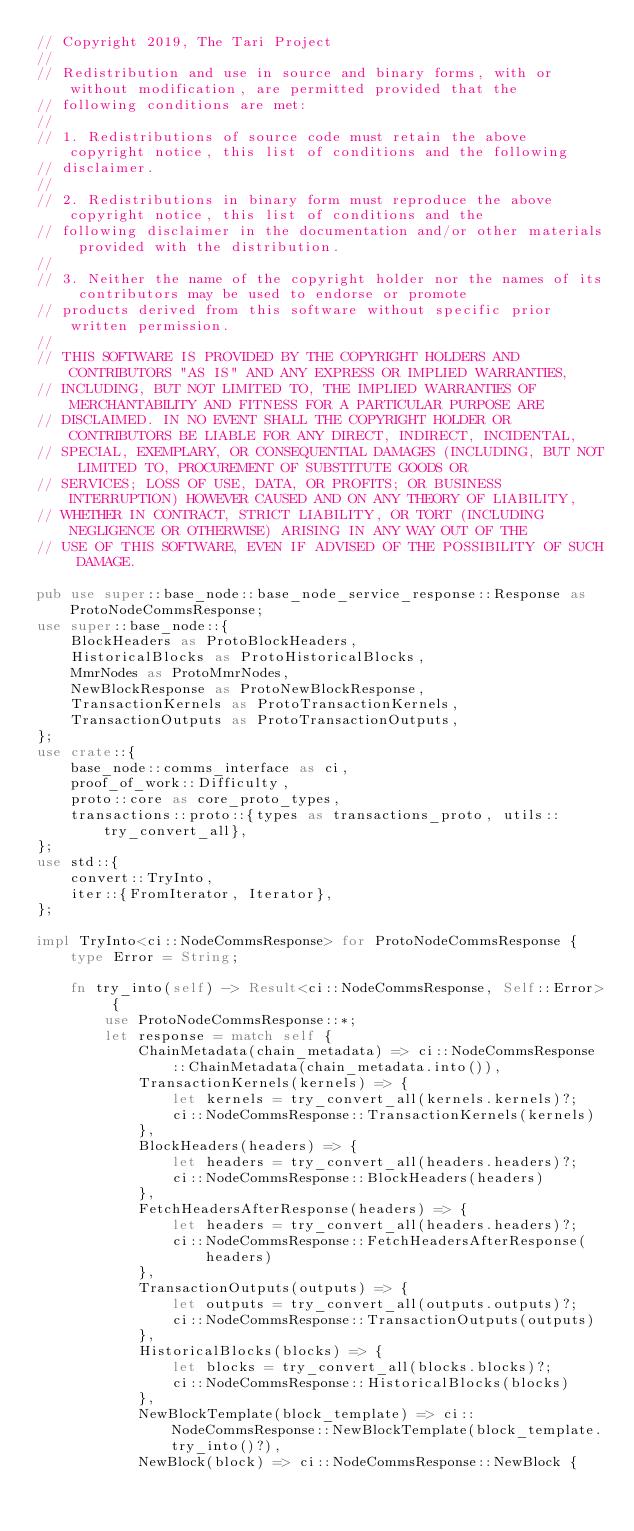Convert code to text. <code><loc_0><loc_0><loc_500><loc_500><_Rust_>// Copyright 2019, The Tari Project
//
// Redistribution and use in source and binary forms, with or without modification, are permitted provided that the
// following conditions are met:
//
// 1. Redistributions of source code must retain the above copyright notice, this list of conditions and the following
// disclaimer.
//
// 2. Redistributions in binary form must reproduce the above copyright notice, this list of conditions and the
// following disclaimer in the documentation and/or other materials provided with the distribution.
//
// 3. Neither the name of the copyright holder nor the names of its contributors may be used to endorse or promote
// products derived from this software without specific prior written permission.
//
// THIS SOFTWARE IS PROVIDED BY THE COPYRIGHT HOLDERS AND CONTRIBUTORS "AS IS" AND ANY EXPRESS OR IMPLIED WARRANTIES,
// INCLUDING, BUT NOT LIMITED TO, THE IMPLIED WARRANTIES OF MERCHANTABILITY AND FITNESS FOR A PARTICULAR PURPOSE ARE
// DISCLAIMED. IN NO EVENT SHALL THE COPYRIGHT HOLDER OR CONTRIBUTORS BE LIABLE FOR ANY DIRECT, INDIRECT, INCIDENTAL,
// SPECIAL, EXEMPLARY, OR CONSEQUENTIAL DAMAGES (INCLUDING, BUT NOT LIMITED TO, PROCUREMENT OF SUBSTITUTE GOODS OR
// SERVICES; LOSS OF USE, DATA, OR PROFITS; OR BUSINESS INTERRUPTION) HOWEVER CAUSED AND ON ANY THEORY OF LIABILITY,
// WHETHER IN CONTRACT, STRICT LIABILITY, OR TORT (INCLUDING NEGLIGENCE OR OTHERWISE) ARISING IN ANY WAY OUT OF THE
// USE OF THIS SOFTWARE, EVEN IF ADVISED OF THE POSSIBILITY OF SUCH DAMAGE.

pub use super::base_node::base_node_service_response::Response as ProtoNodeCommsResponse;
use super::base_node::{
    BlockHeaders as ProtoBlockHeaders,
    HistoricalBlocks as ProtoHistoricalBlocks,
    MmrNodes as ProtoMmrNodes,
    NewBlockResponse as ProtoNewBlockResponse,
    TransactionKernels as ProtoTransactionKernels,
    TransactionOutputs as ProtoTransactionOutputs,
};
use crate::{
    base_node::comms_interface as ci,
    proof_of_work::Difficulty,
    proto::core as core_proto_types,
    transactions::proto::{types as transactions_proto, utils::try_convert_all},
};
use std::{
    convert::TryInto,
    iter::{FromIterator, Iterator},
};

impl TryInto<ci::NodeCommsResponse> for ProtoNodeCommsResponse {
    type Error = String;

    fn try_into(self) -> Result<ci::NodeCommsResponse, Self::Error> {
        use ProtoNodeCommsResponse::*;
        let response = match self {
            ChainMetadata(chain_metadata) => ci::NodeCommsResponse::ChainMetadata(chain_metadata.into()),
            TransactionKernels(kernels) => {
                let kernels = try_convert_all(kernels.kernels)?;
                ci::NodeCommsResponse::TransactionKernels(kernels)
            },
            BlockHeaders(headers) => {
                let headers = try_convert_all(headers.headers)?;
                ci::NodeCommsResponse::BlockHeaders(headers)
            },
            FetchHeadersAfterResponse(headers) => {
                let headers = try_convert_all(headers.headers)?;
                ci::NodeCommsResponse::FetchHeadersAfterResponse(headers)
            },
            TransactionOutputs(outputs) => {
                let outputs = try_convert_all(outputs.outputs)?;
                ci::NodeCommsResponse::TransactionOutputs(outputs)
            },
            HistoricalBlocks(blocks) => {
                let blocks = try_convert_all(blocks.blocks)?;
                ci::NodeCommsResponse::HistoricalBlocks(blocks)
            },
            NewBlockTemplate(block_template) => ci::NodeCommsResponse::NewBlockTemplate(block_template.try_into()?),
            NewBlock(block) => ci::NodeCommsResponse::NewBlock {</code> 